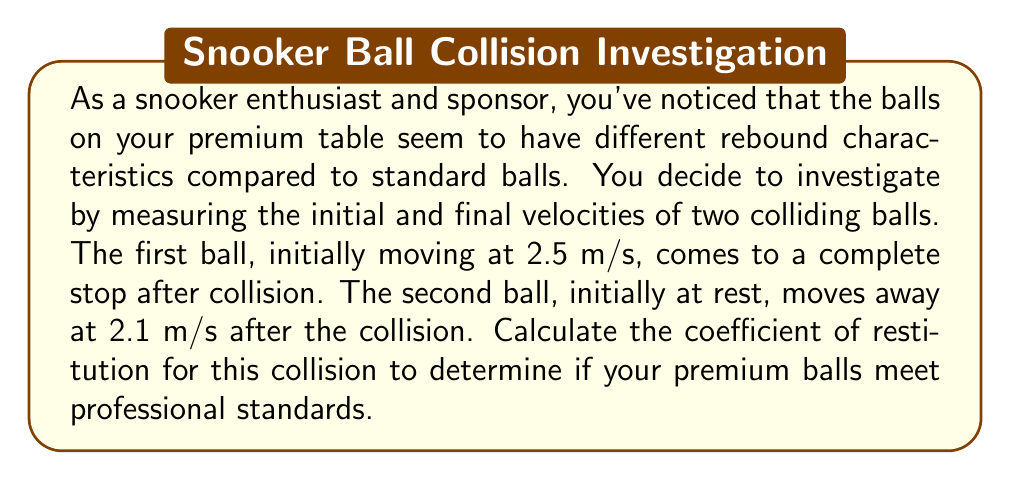Can you answer this question? To solve this problem, we'll use the definition of the coefficient of restitution and the given information about the velocities of the two snooker balls.

Step 1: Define the variables
Let's define:
$v_{1i}$ = initial velocity of the first ball
$v_{2i}$ = initial velocity of the second ball
$v_{1f}$ = final velocity of the first ball
$v_{2f}$ = final velocity of the second ball
$e$ = coefficient of restitution

Step 2: Identify the known values
$v_{1i} = 2.5$ m/s
$v_{2i} = 0$ m/s (initially at rest)
$v_{1f} = 0$ m/s (comes to a complete stop)
$v_{2f} = 2.1$ m/s

Step 3: Recall the formula for the coefficient of restitution
The coefficient of restitution is defined as the ratio of the relative velocity of separation to the relative velocity of approach:

$$ e = \frac{v_{2f} - v_{1f}}{v_{1i} - v_{2i}} $$

Step 4: Substitute the known values into the formula
$$ e = \frac{2.1 - 0}{2.5 - 0} $$

Step 5: Simplify and calculate
$$ e = \frac{2.1}{2.5} = 0.84 $$

Therefore, the coefficient of restitution for the collision between your premium snooker balls is 0.84 or 84%.
Answer: 0.84 